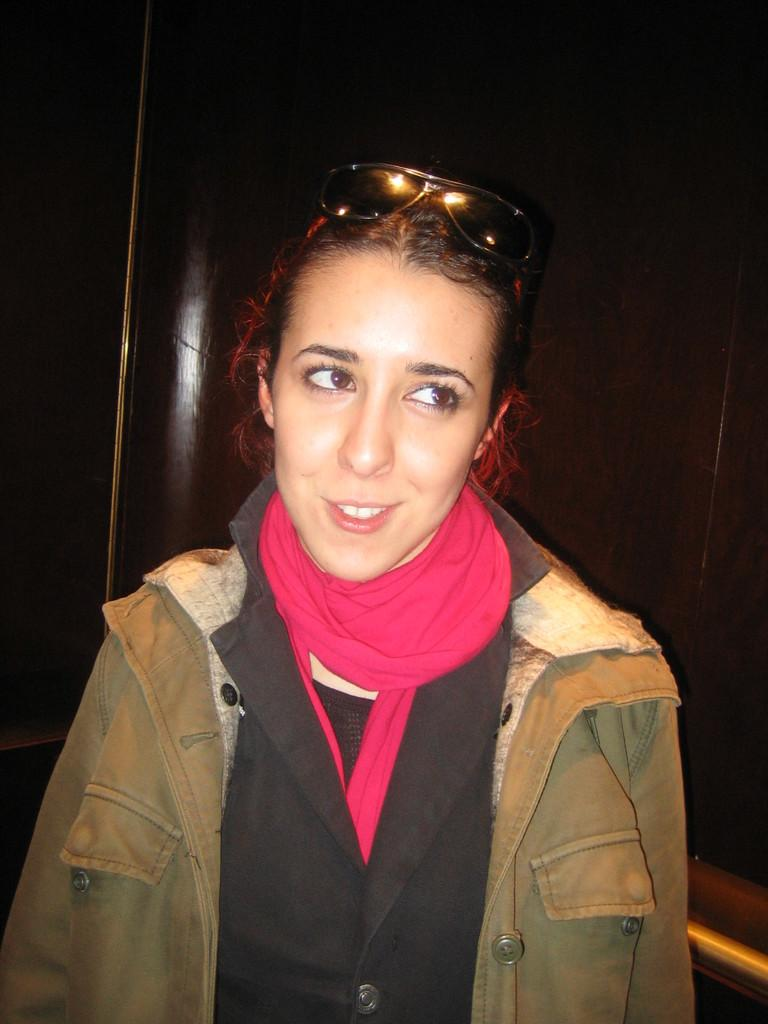Who is the main subject in the image? There is a woman in the image. What is the woman doing in the image? The woman is standing. What accessory is the woman wearing in the image? The woman is wearing a scarf. What additional item can be seen in the image? Goggles are present in the image. How many quince can be seen in the image? A: There are no quince present in the image. What is the woman giving birth to in the image? There is no indication of a birth or any related activity in the image. 